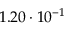<formula> <loc_0><loc_0><loc_500><loc_500>1 . 2 0 \cdot 1 0 ^ { - 1 }</formula> 